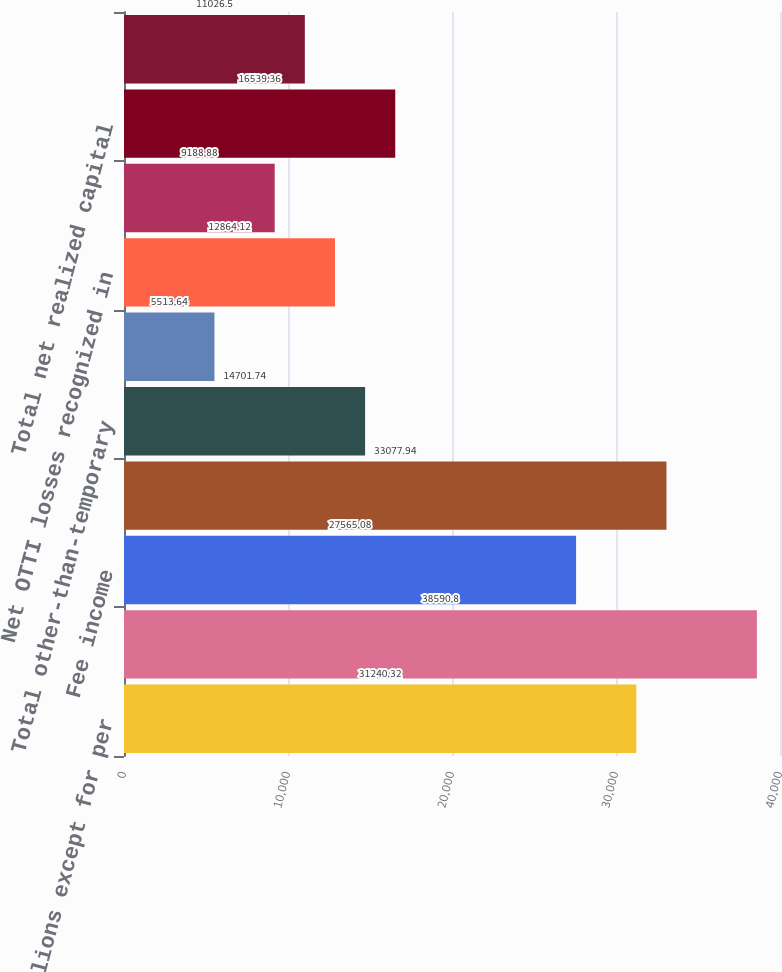Convert chart. <chart><loc_0><loc_0><loc_500><loc_500><bar_chart><fcel>(In millions except for per<fcel>Earned premiums<fcel>Fee income<fcel>Net investment income<fcel>Total other-than-temporary<fcel>OTTI losses recognized in<fcel>Net OTTI losses recognized in<fcel>Other net realized capital<fcel>Total net realized capital<fcel>Other revenues<nl><fcel>31240.3<fcel>38590.8<fcel>27565.1<fcel>33077.9<fcel>14701.7<fcel>5513.64<fcel>12864.1<fcel>9188.88<fcel>16539.4<fcel>11026.5<nl></chart> 